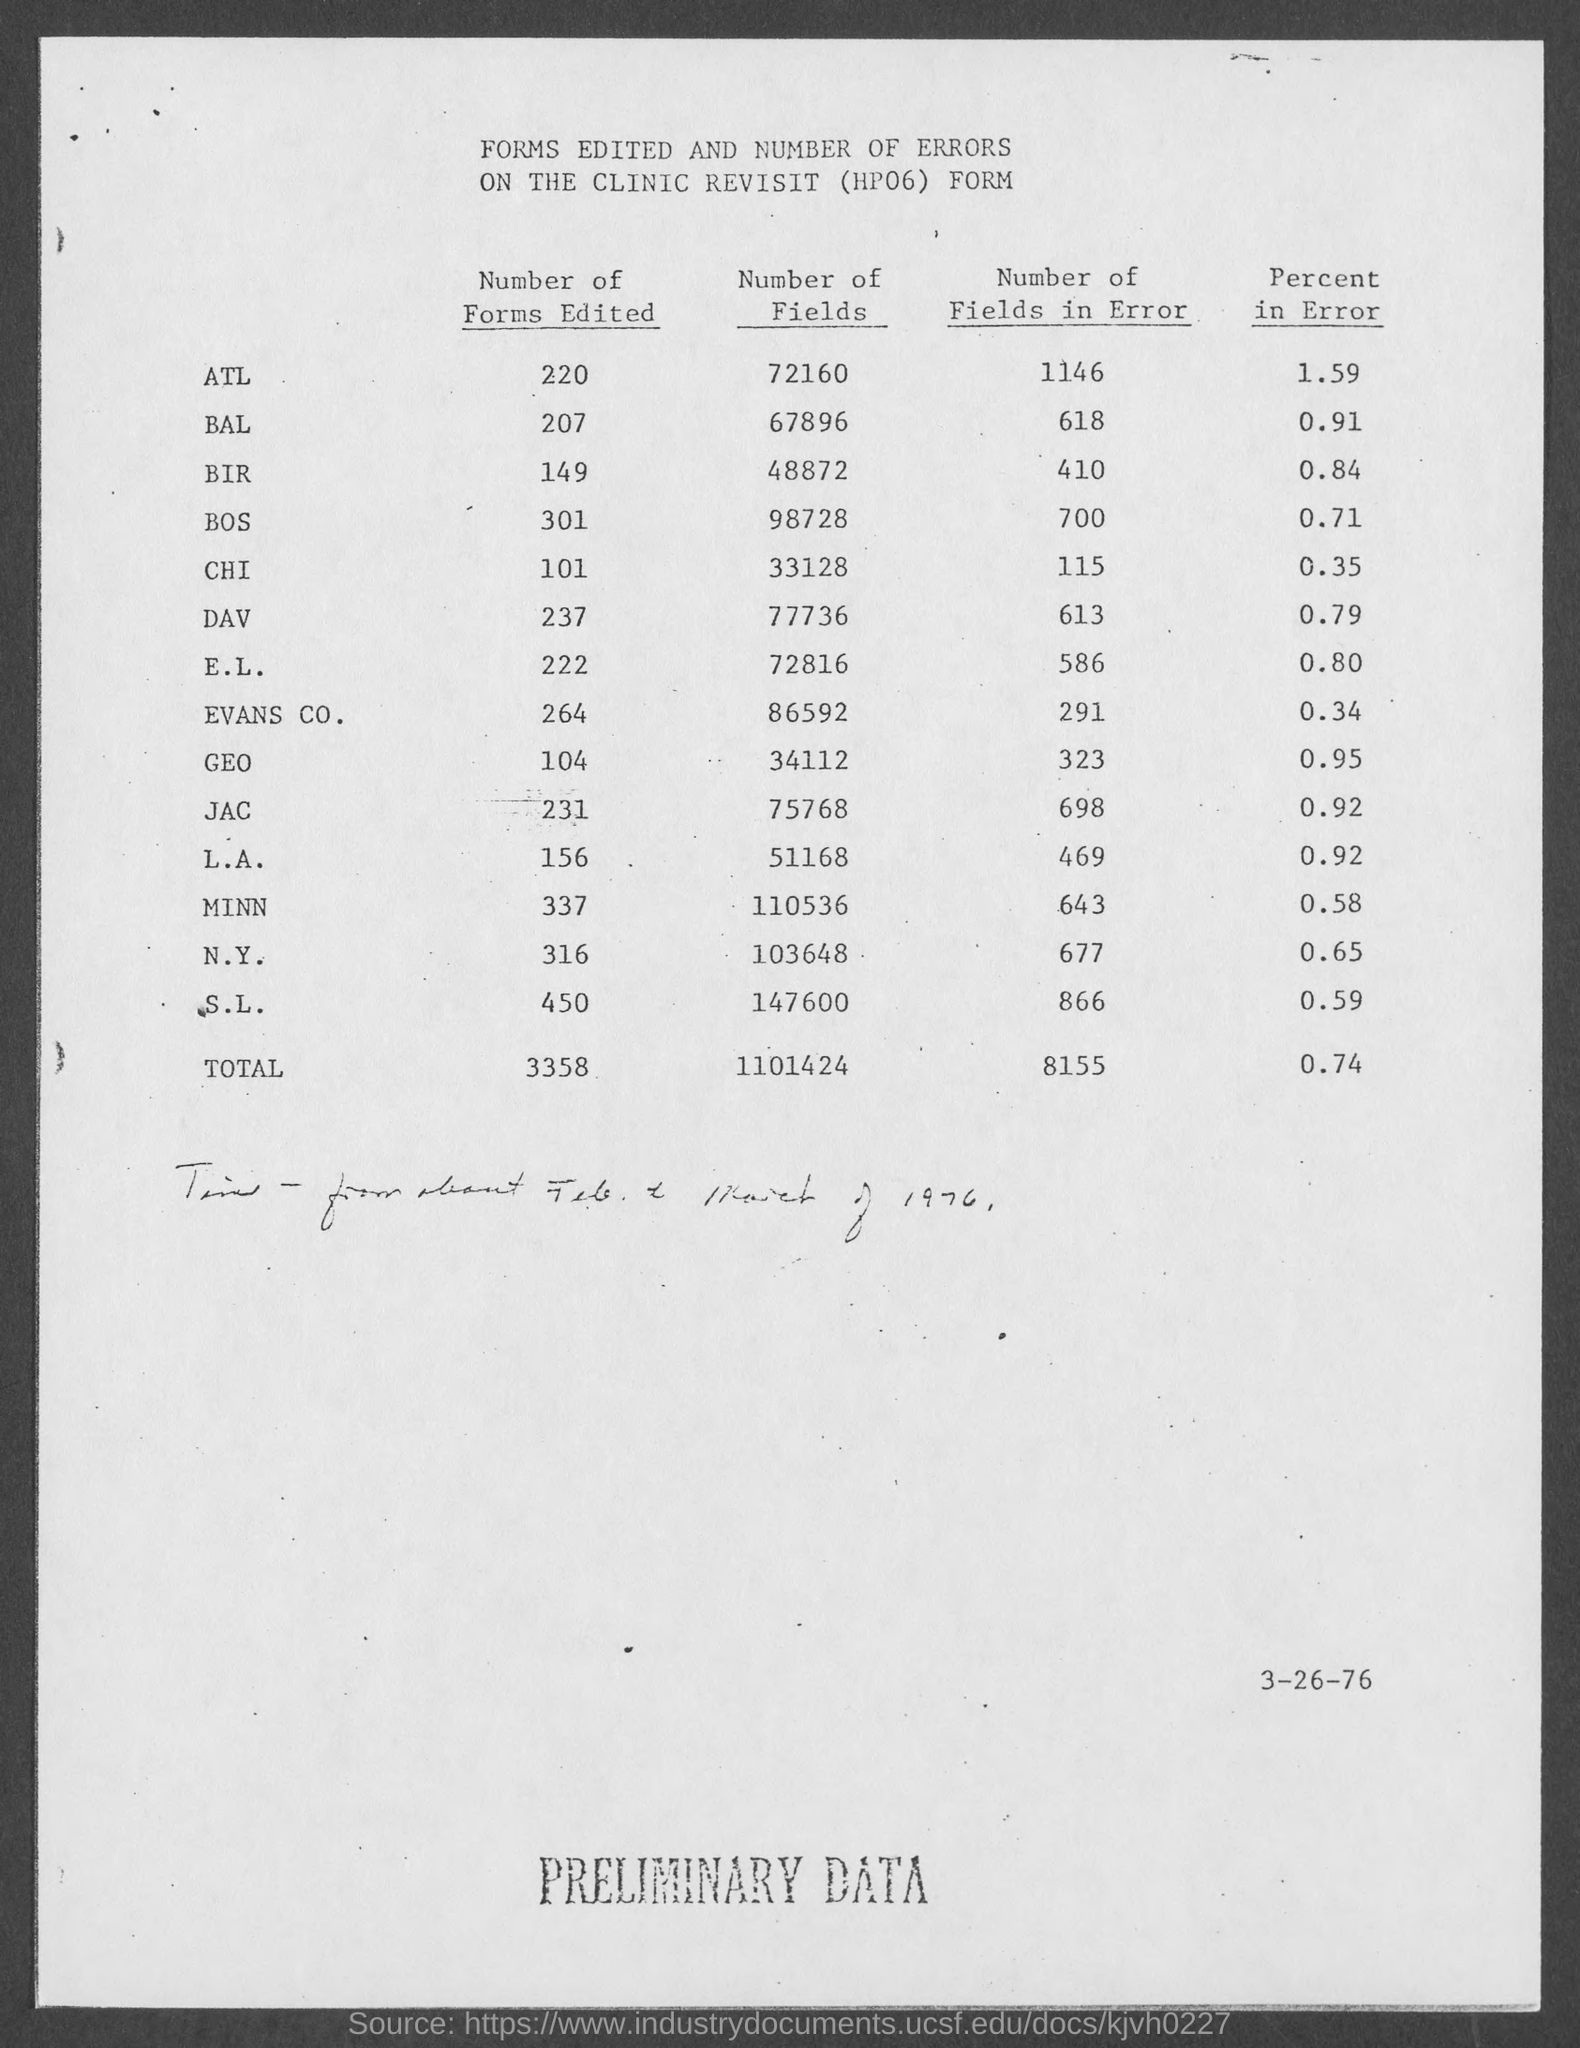How many forms of ATL are edited?
Your answer should be compact. 220. How many fields are there for BAL?
Ensure brevity in your answer.  67896. How many fields of DAV have error?
Provide a short and direct response. 613. What is the percent of error of JAC?
Offer a very short reply. 0.92. What is the total number of forms edited?
Offer a very short reply. 3358. 